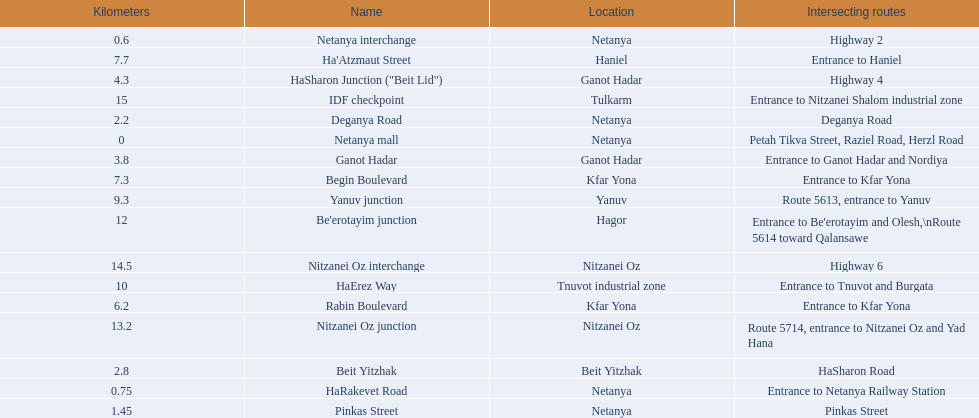Could you help me parse every detail presented in this table? {'header': ['Kilometers', 'Name', 'Location', 'Intersecting routes'], 'rows': [['0.6', 'Netanya interchange', 'Netanya', 'Highway 2'], ['7.7', "Ha'Atzmaut Street", 'Haniel', 'Entrance to Haniel'], ['4.3', 'HaSharon Junction ("Beit Lid")', 'Ganot Hadar', 'Highway 4'], ['15', 'IDF checkpoint', 'Tulkarm', 'Entrance to Nitzanei Shalom industrial zone'], ['2.2', 'Deganya Road', 'Netanya', 'Deganya Road'], ['0', 'Netanya mall', 'Netanya', 'Petah Tikva Street, Raziel Road, Herzl Road'], ['3.8', 'Ganot Hadar', 'Ganot Hadar', 'Entrance to Ganot Hadar and Nordiya'], ['7.3', 'Begin Boulevard', 'Kfar Yona', 'Entrance to Kfar Yona'], ['9.3', 'Yanuv junction', 'Yanuv', 'Route 5613, entrance to Yanuv'], ['12', "Be'erotayim junction", 'Hagor', "Entrance to Be'erotayim and Olesh,\\nRoute 5614 toward Qalansawe"], ['14.5', 'Nitzanei Oz interchange', 'Nitzanei Oz', 'Highway 6'], ['10', 'HaErez Way', 'Tnuvot industrial zone', 'Entrance to Tnuvot and Burgata'], ['6.2', 'Rabin Boulevard', 'Kfar Yona', 'Entrance to Kfar Yona'], ['13.2', 'Nitzanei Oz junction', 'Nitzanei Oz', 'Route 5714, entrance to Nitzanei Oz and Yad Hana'], ['2.8', 'Beit Yitzhak', 'Beit Yitzhak', 'HaSharon Road'], ['0.75', 'HaRakevet Road', 'Netanya', 'Entrance to Netanya Railway Station'], ['1.45', 'Pinkas Street', 'Netanya', 'Pinkas Street']]} What are all the names? Netanya mall, Netanya interchange, HaRakevet Road, Pinkas Street, Deganya Road, Beit Yitzhak, Ganot Hadar, HaSharon Junction ("Beit Lid"), Rabin Boulevard, Begin Boulevard, Ha'Atzmaut Street, Yanuv junction, HaErez Way, Be'erotayim junction, Nitzanei Oz junction, Nitzanei Oz interchange, IDF checkpoint. Where do they intersect? Petah Tikva Street, Raziel Road, Herzl Road, Highway 2, Entrance to Netanya Railway Station, Pinkas Street, Deganya Road, HaSharon Road, Entrance to Ganot Hadar and Nordiya, Highway 4, Entrance to Kfar Yona, Entrance to Kfar Yona, Entrance to Haniel, Route 5613, entrance to Yanuv, Entrance to Tnuvot and Burgata, Entrance to Be'erotayim and Olesh,\nRoute 5614 toward Qalansawe, Route 5714, entrance to Nitzanei Oz and Yad Hana, Highway 6, Entrance to Nitzanei Shalom industrial zone. And which shares an intersection with rabin boulevard? Begin Boulevard. 